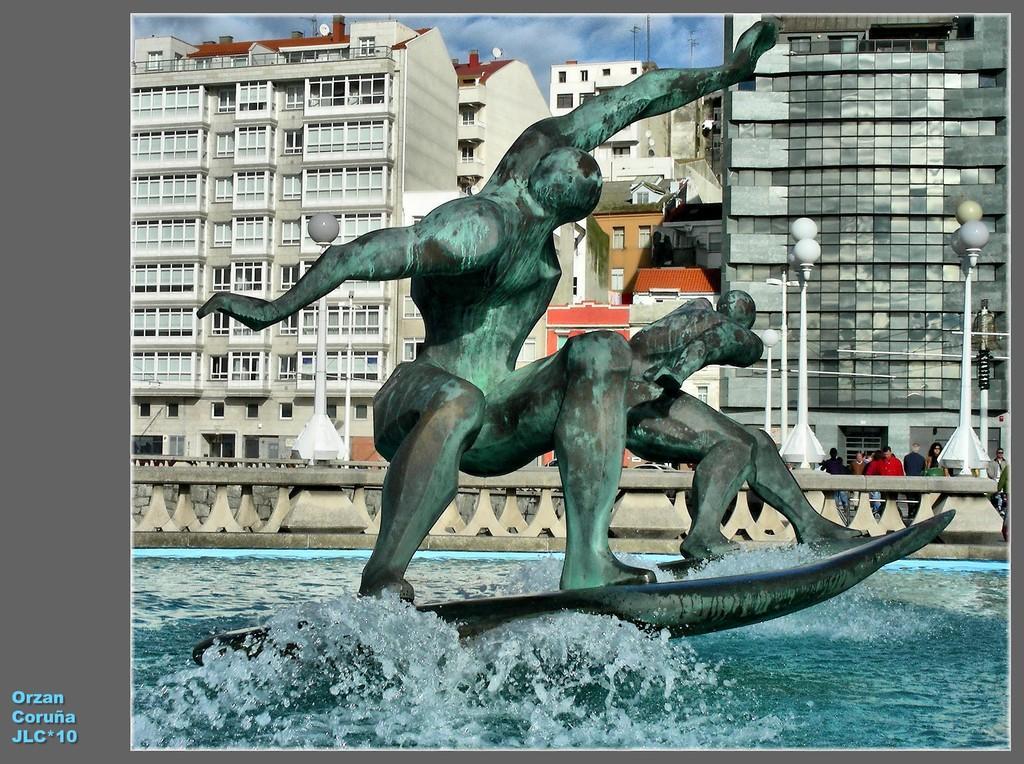How would you summarize this image in a sentence or two? In this picture I can observe statues in the middle of the picture. On the right side I can observe some people on the land. In the background there are buildings and sky. In the bottom of the picture I can observe river. 